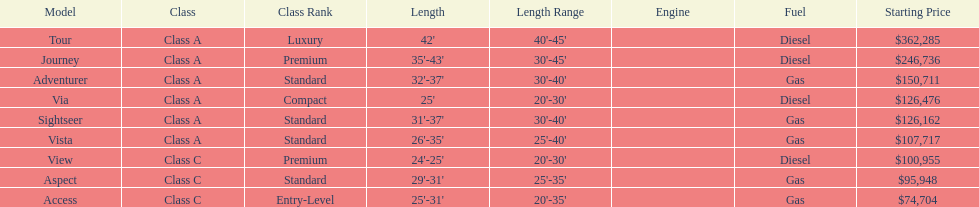How many models are available in lengths longer than 30 feet? 7. 